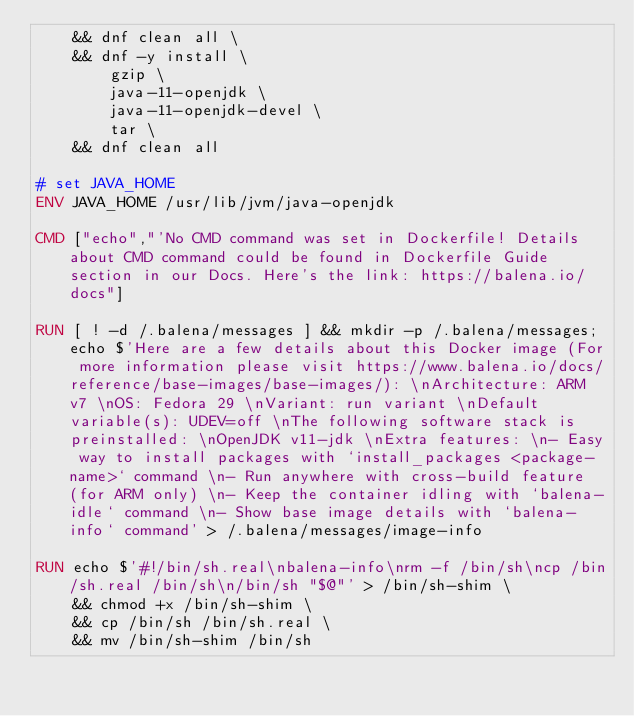<code> <loc_0><loc_0><loc_500><loc_500><_Dockerfile_>	&& dnf clean all \
	&& dnf -y install \
		gzip \
		java-11-openjdk \
		java-11-openjdk-devel \
		tar \
	&& dnf clean all

# set JAVA_HOME
ENV JAVA_HOME /usr/lib/jvm/java-openjdk

CMD ["echo","'No CMD command was set in Dockerfile! Details about CMD command could be found in Dockerfile Guide section in our Docs. Here's the link: https://balena.io/docs"]

RUN [ ! -d /.balena/messages ] && mkdir -p /.balena/messages; echo $'Here are a few details about this Docker image (For more information please visit https://www.balena.io/docs/reference/base-images/base-images/): \nArchitecture: ARM v7 \nOS: Fedora 29 \nVariant: run variant \nDefault variable(s): UDEV=off \nThe following software stack is preinstalled: \nOpenJDK v11-jdk \nExtra features: \n- Easy way to install packages with `install_packages <package-name>` command \n- Run anywhere with cross-build feature  (for ARM only) \n- Keep the container idling with `balena-idle` command \n- Show base image details with `balena-info` command' > /.balena/messages/image-info

RUN echo $'#!/bin/sh.real\nbalena-info\nrm -f /bin/sh\ncp /bin/sh.real /bin/sh\n/bin/sh "$@"' > /bin/sh-shim \
	&& chmod +x /bin/sh-shim \
	&& cp /bin/sh /bin/sh.real \
	&& mv /bin/sh-shim /bin/sh</code> 